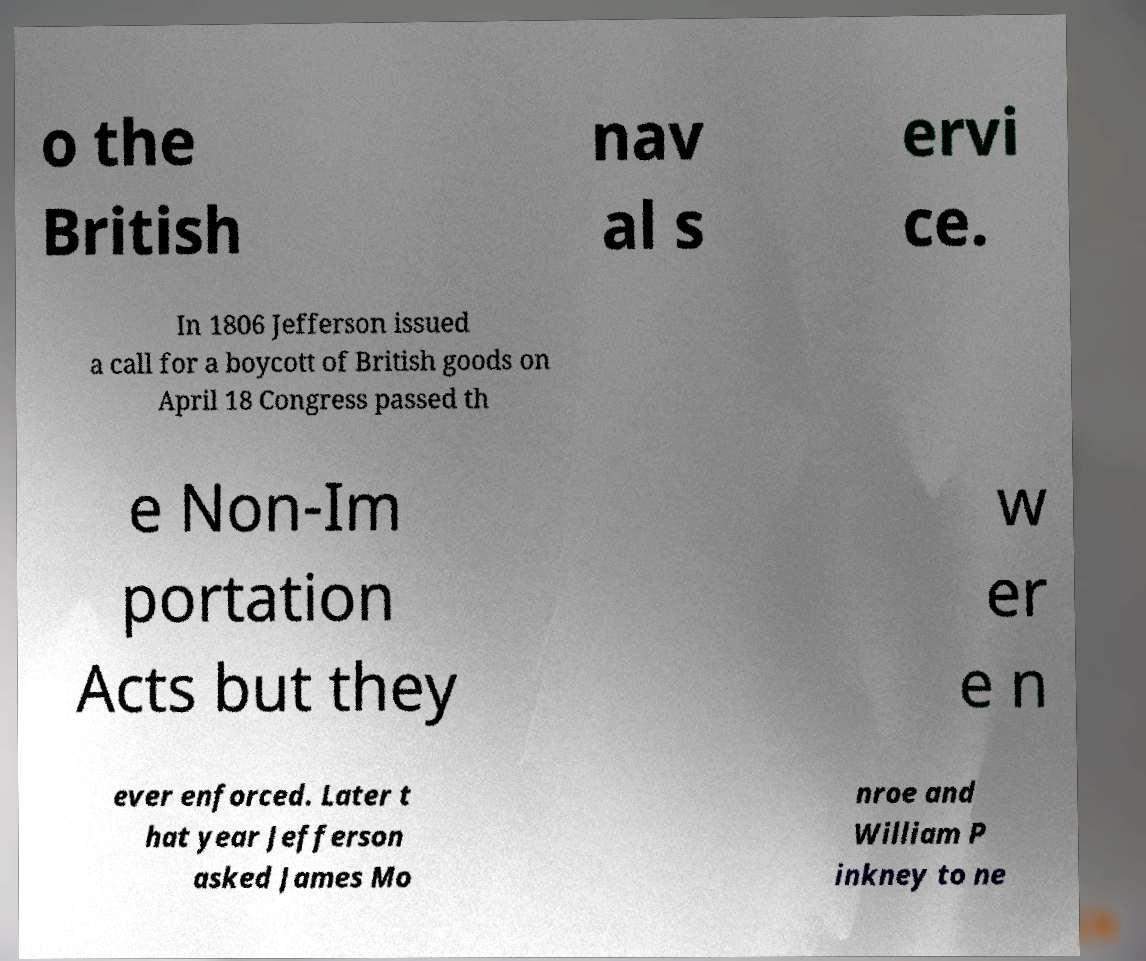Can you read and provide the text displayed in the image?This photo seems to have some interesting text. Can you extract and type it out for me? o the British nav al s ervi ce. In 1806 Jefferson issued a call for a boycott of British goods on April 18 Congress passed th e Non-Im portation Acts but they w er e n ever enforced. Later t hat year Jefferson asked James Mo nroe and William P inkney to ne 